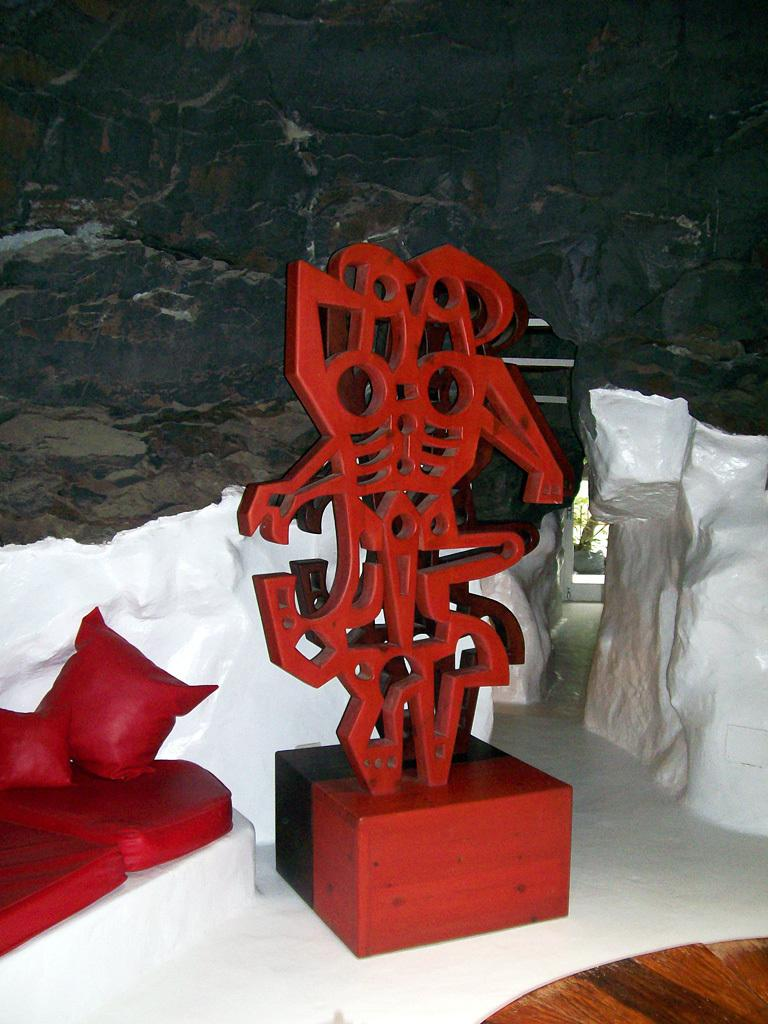What objects can be seen in the image? There are toys in the image. What can be seen in the background of the image? There is a wall visible in the background of the image. What type of blade is being used to cut the parcel in the image? There is no parcel or blade present in the image; it only features toys and a wall in the background. 